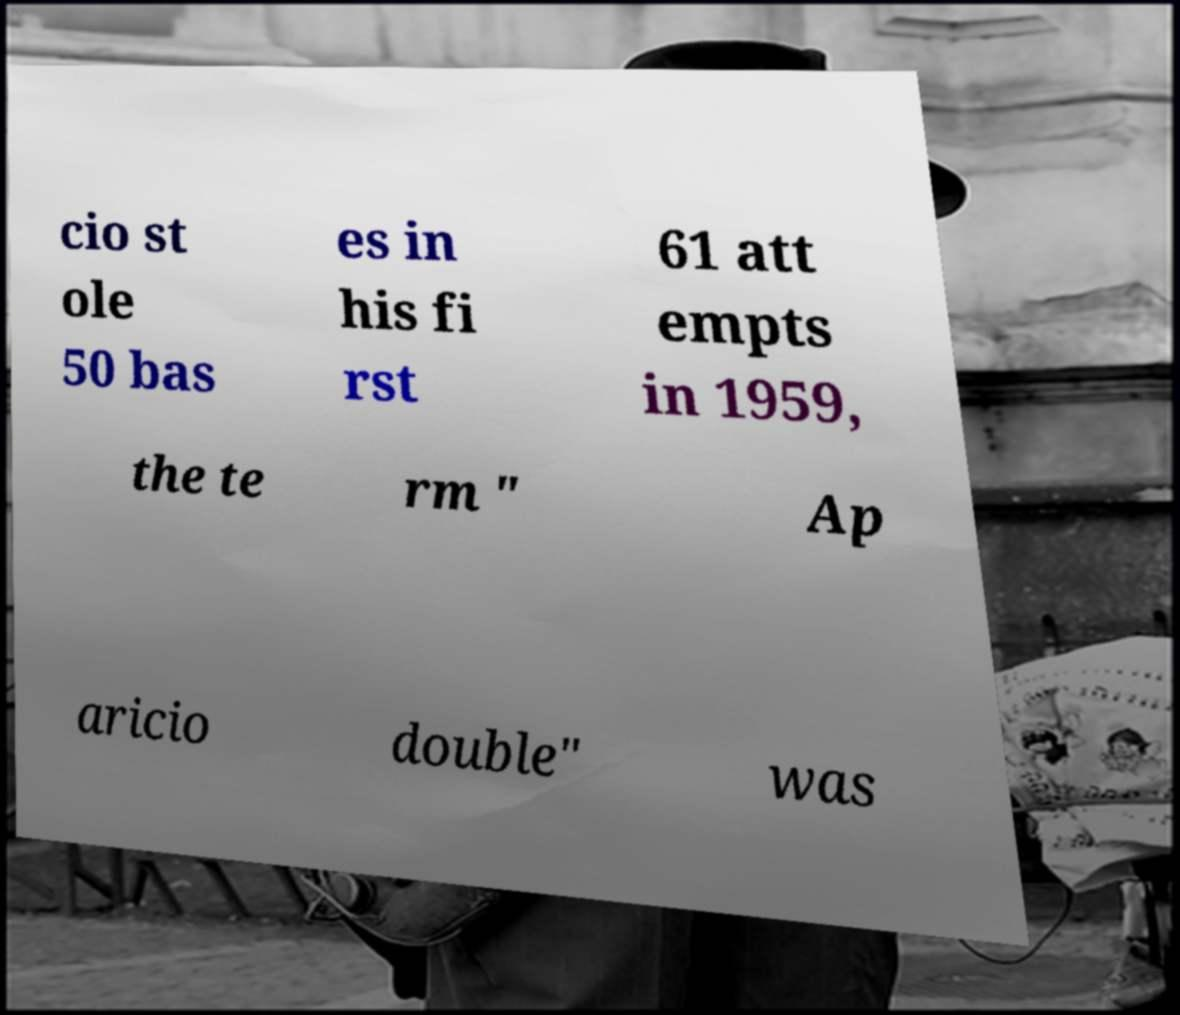I need the written content from this picture converted into text. Can you do that? cio st ole 50 bas es in his fi rst 61 att empts in 1959, the te rm " Ap aricio double" was 